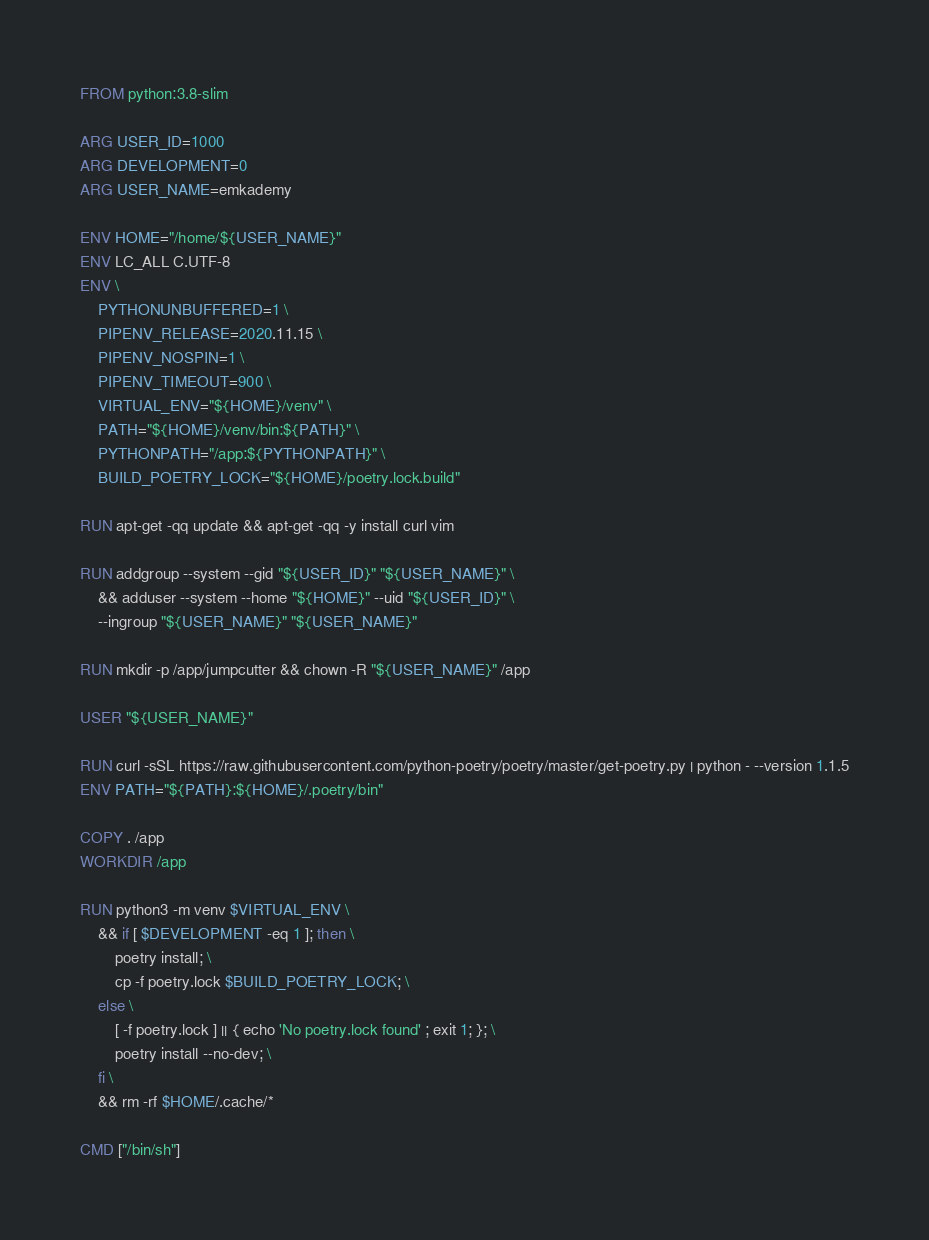Convert code to text. <code><loc_0><loc_0><loc_500><loc_500><_Dockerfile_>FROM python:3.8-slim

ARG USER_ID=1000
ARG DEVELOPMENT=0
ARG USER_NAME=emkademy

ENV HOME="/home/${USER_NAME}"
ENV LC_ALL C.UTF-8
ENV \
    PYTHONUNBUFFERED=1 \
    PIPENV_RELEASE=2020.11.15 \
    PIPENV_NOSPIN=1 \
    PIPENV_TIMEOUT=900 \
    VIRTUAL_ENV="${HOME}/venv" \
    PATH="${HOME}/venv/bin:${PATH}" \
    PYTHONPATH="/app:${PYTHONPATH}" \ 
    BUILD_POETRY_LOCK="${HOME}/poetry.lock.build"

RUN apt-get -qq update && apt-get -qq -y install curl vim

RUN addgroup --system --gid "${USER_ID}" "${USER_NAME}" \
    && adduser --system --home "${HOME}" --uid "${USER_ID}" \
    --ingroup "${USER_NAME}" "${USER_NAME}"

RUN mkdir -p /app/jumpcutter && chown -R "${USER_NAME}" /app

USER "${USER_NAME}"

RUN curl -sSL https://raw.githubusercontent.com/python-poetry/poetry/master/get-poetry.py | python - --version 1.1.5
ENV PATH="${PATH}:${HOME}/.poetry/bin"

COPY . /app
WORKDIR /app

RUN python3 -m venv $VIRTUAL_ENV \
    && if [ $DEVELOPMENT -eq 1 ]; then \
        poetry install; \
        cp -f poetry.lock $BUILD_POETRY_LOCK; \
    else \
        [ -f poetry.lock ] || { echo 'No poetry.lock found' ; exit 1; }; \
        poetry install --no-dev; \
    fi \
    && rm -rf $HOME/.cache/*

CMD ["/bin/sh"]

</code> 